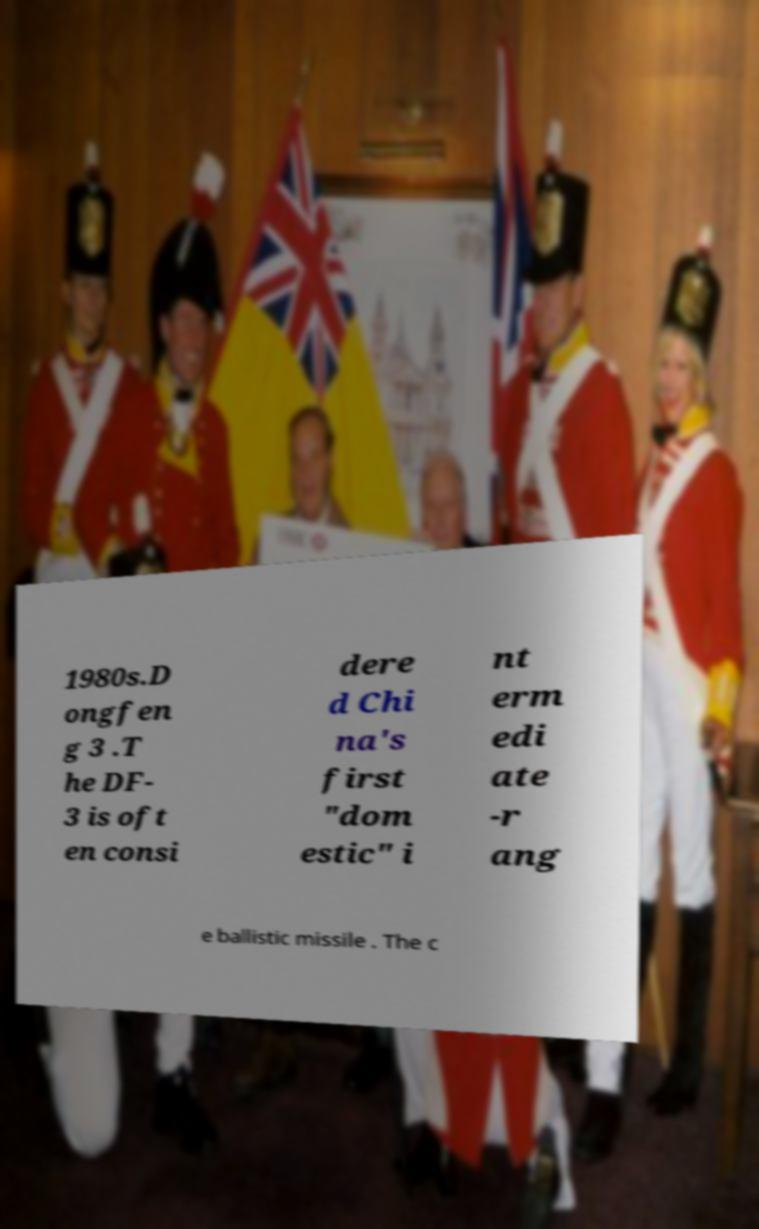Could you assist in decoding the text presented in this image and type it out clearly? 1980s.D ongfen g 3 .T he DF- 3 is oft en consi dere d Chi na's first "dom estic" i nt erm edi ate -r ang e ballistic missile . The c 